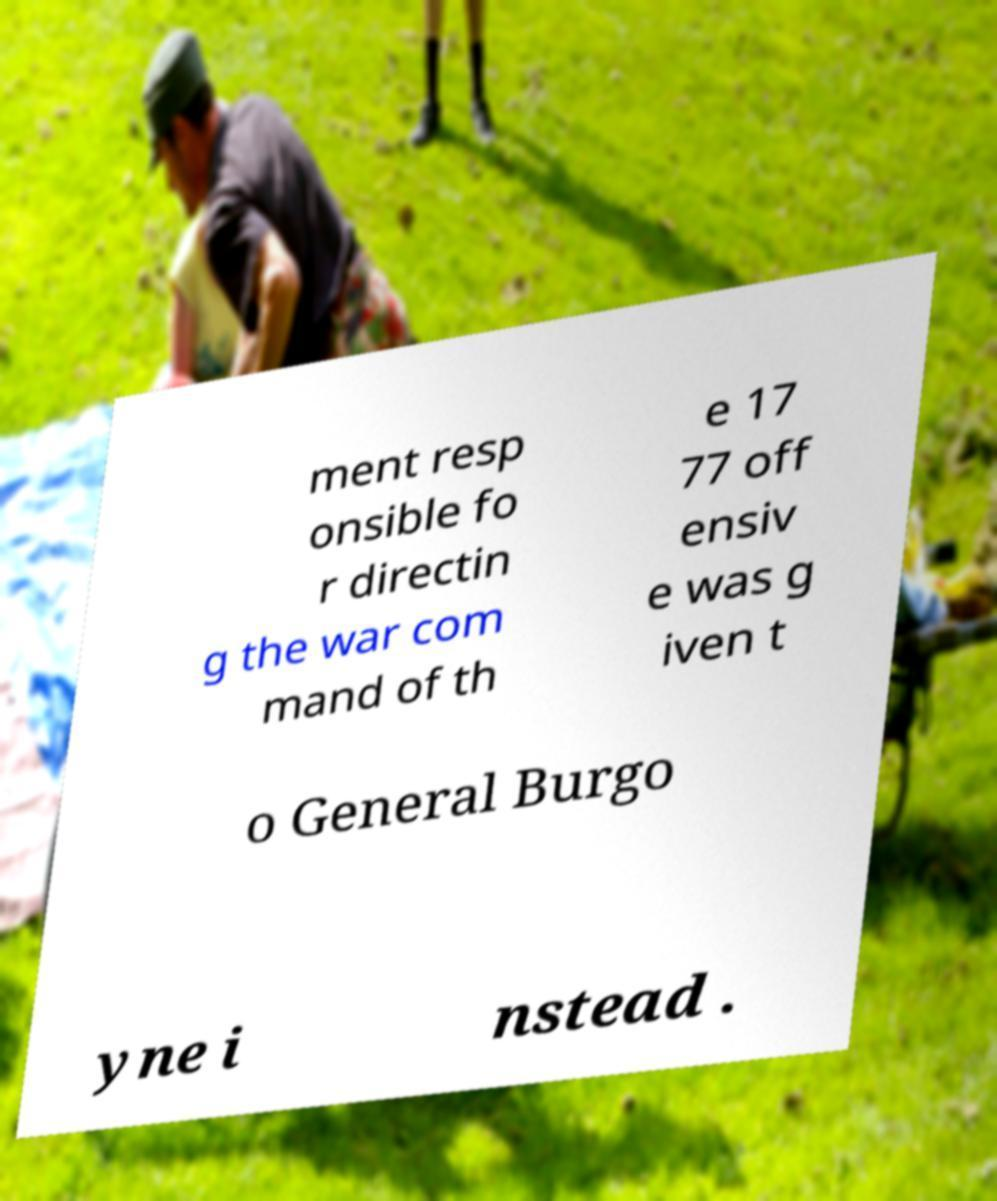Please identify and transcribe the text found in this image. ment resp onsible fo r directin g the war com mand of th e 17 77 off ensiv e was g iven t o General Burgo yne i nstead . 